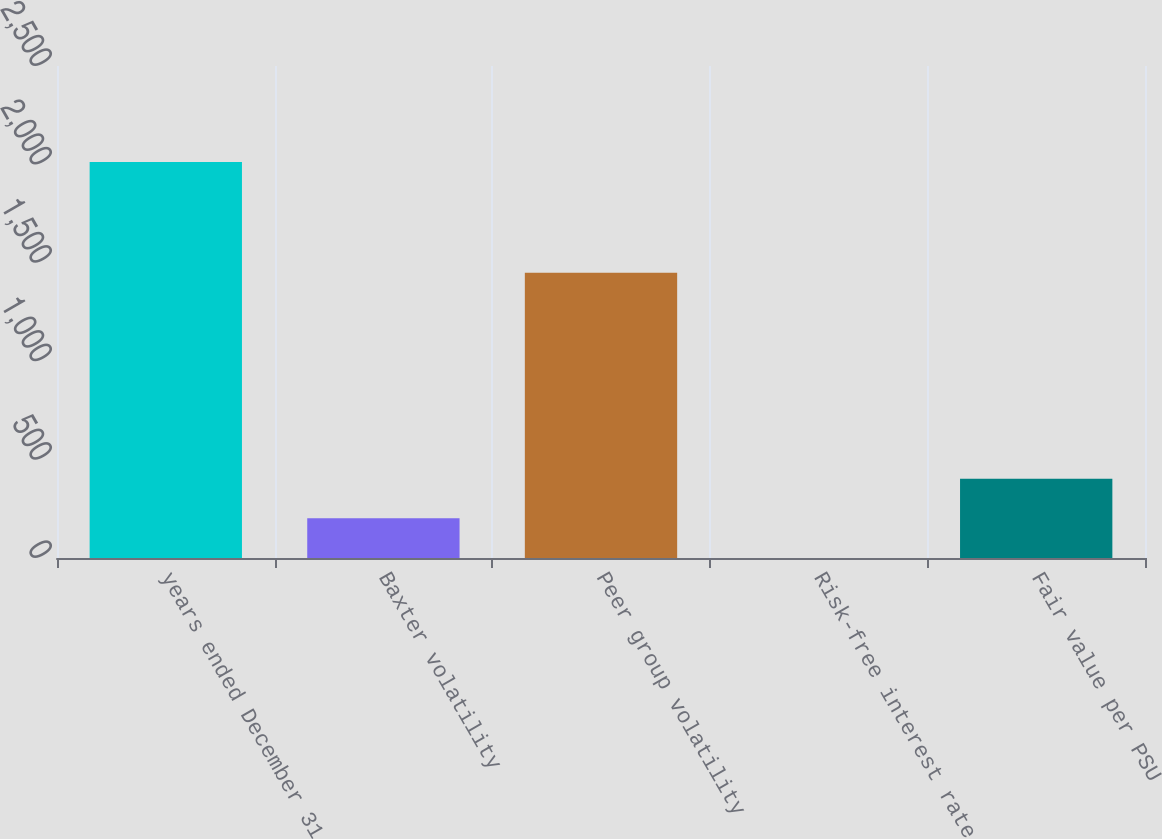Convert chart to OTSL. <chart><loc_0><loc_0><loc_500><loc_500><bar_chart><fcel>years ended December 31<fcel>Baxter volatility<fcel>Peer group volatility<fcel>Risk-free interest rate<fcel>Fair value per PSU<nl><fcel>2012<fcel>201.56<fcel>1450<fcel>0.4<fcel>402.72<nl></chart> 